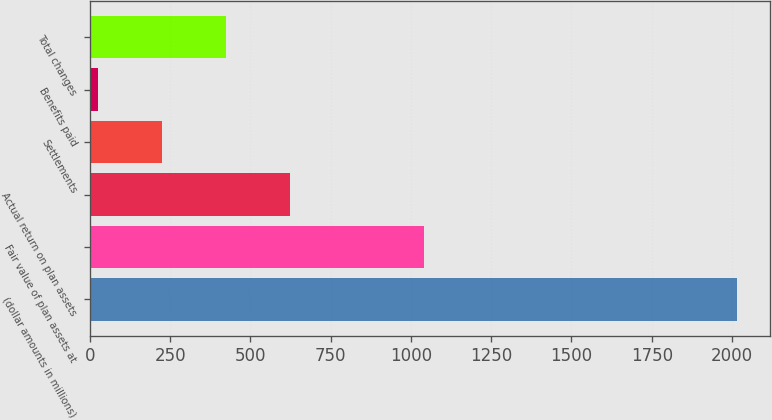<chart> <loc_0><loc_0><loc_500><loc_500><bar_chart><fcel>(dollar amounts in millions)<fcel>Fair value of plan assets at<fcel>Actual return on plan assets<fcel>Settlements<fcel>Benefits paid<fcel>Total changes<nl><fcel>2017<fcel>1040<fcel>624<fcel>226<fcel>27<fcel>425<nl></chart> 